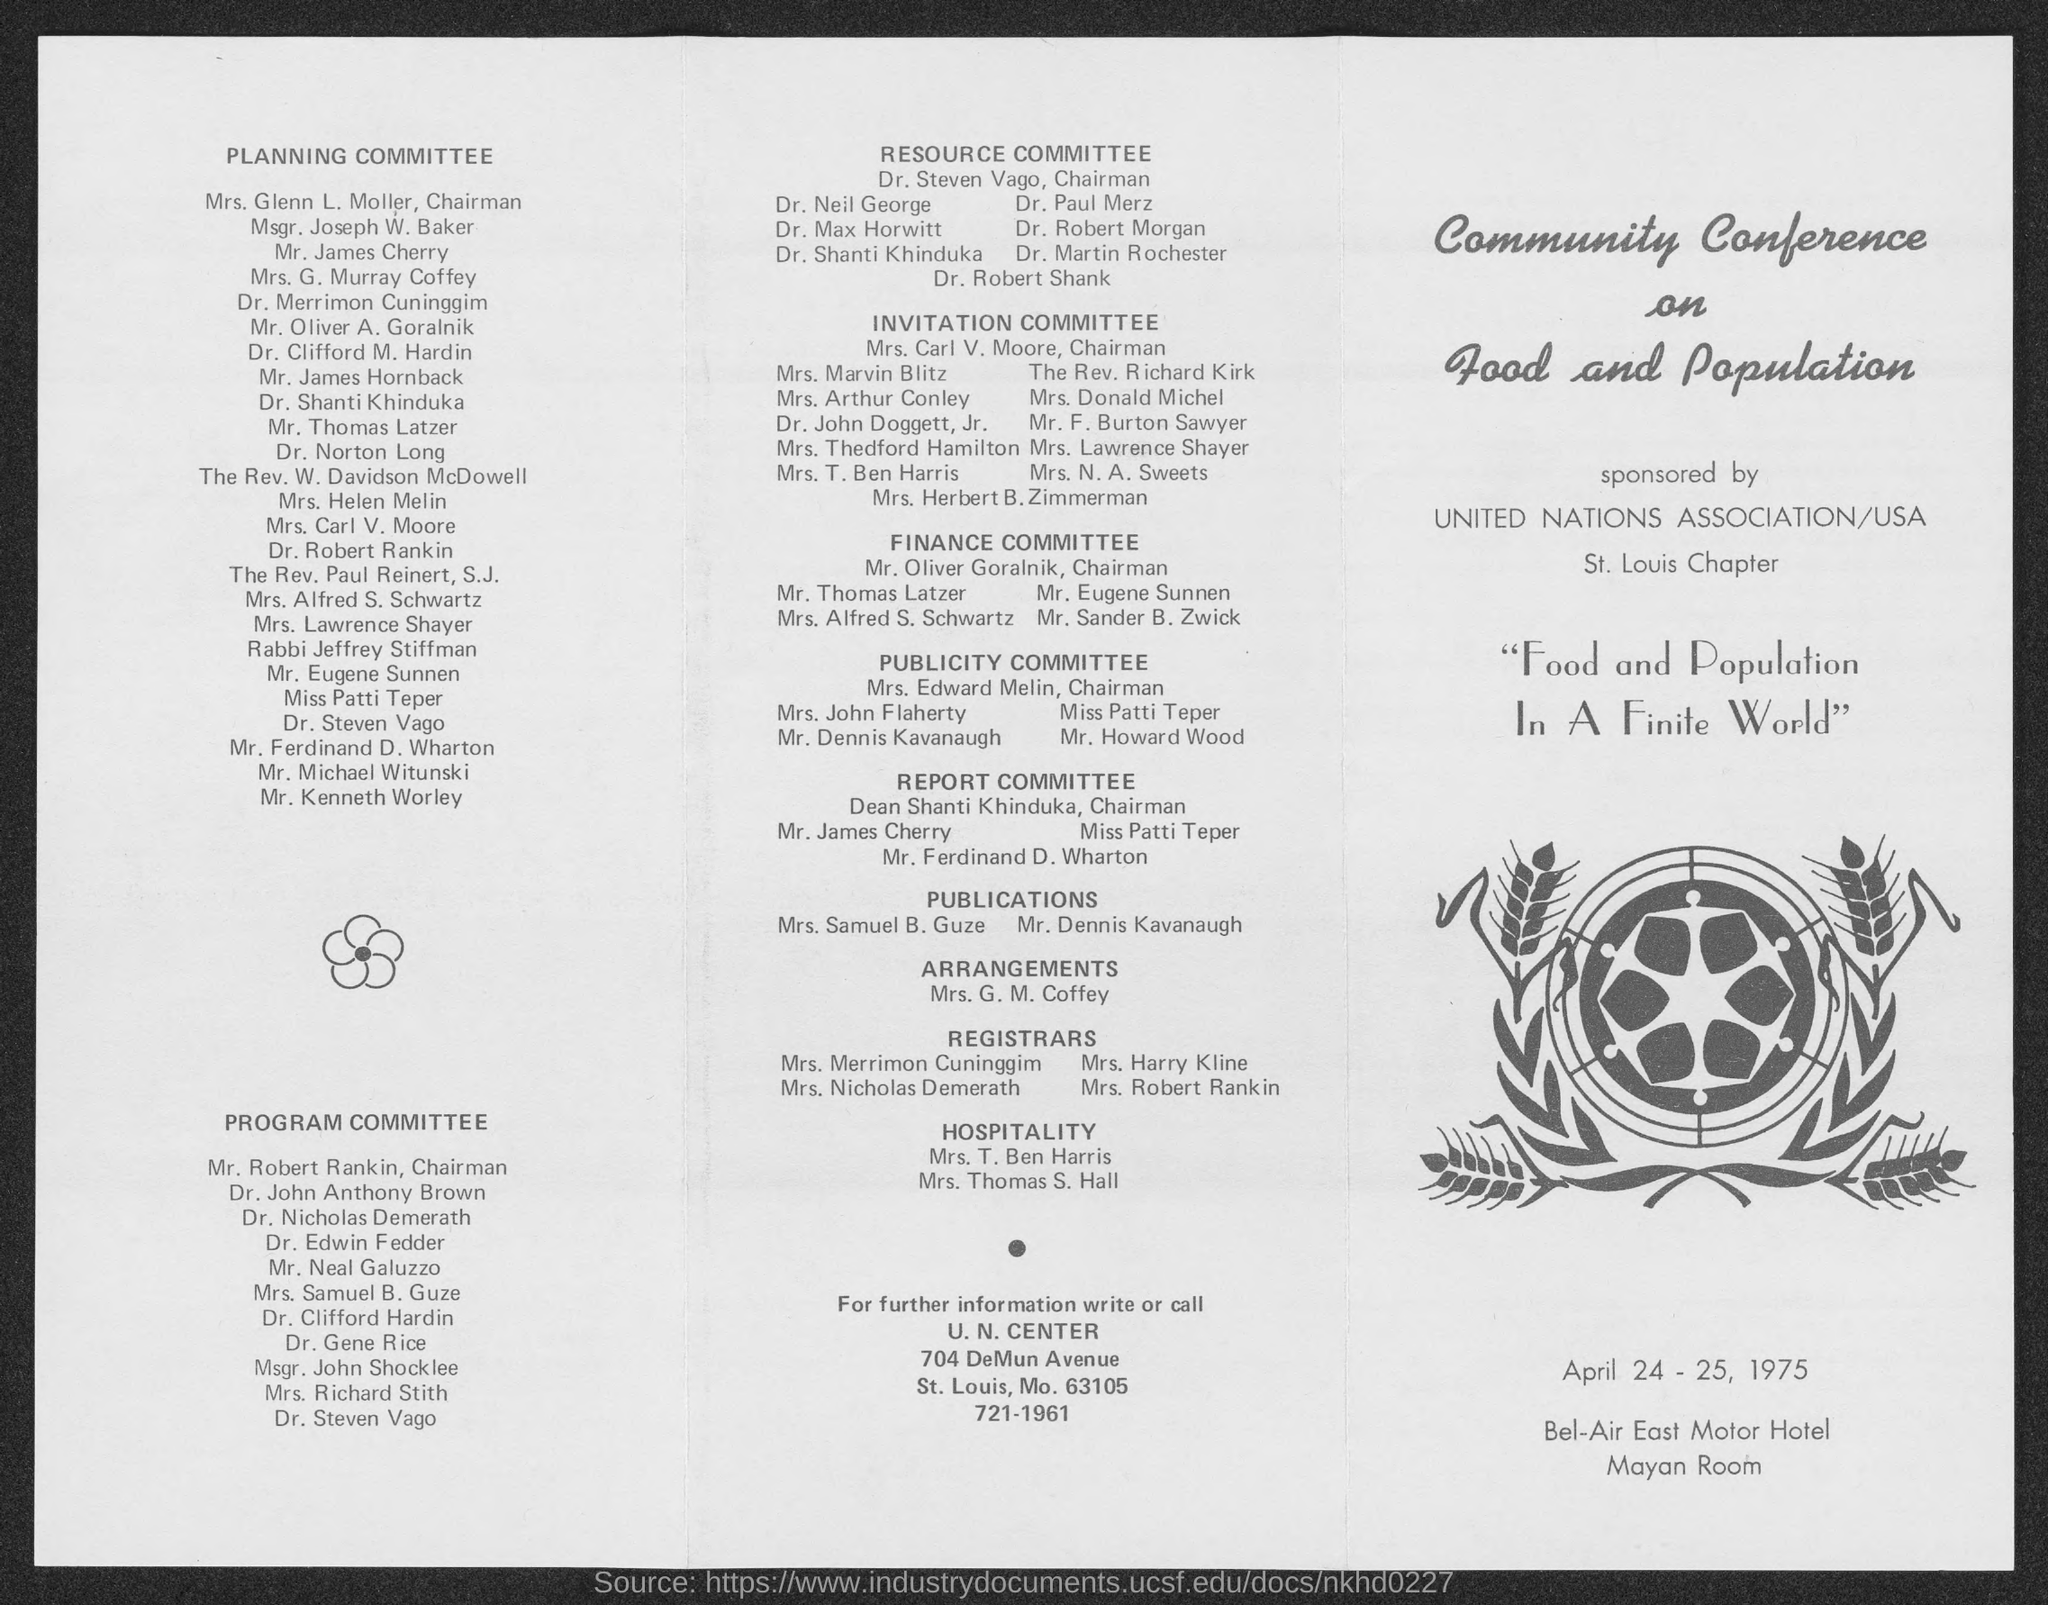Who sponsores Community Conference on Food and Population?
Keep it short and to the point. UNITED NATIONS ASSOCIATION/USA St. Lous Chapter. When was the Community Conference on Food and Population held?
Give a very brief answer. APRIL 24 - 25, 1975. In which place, the Community Conference on Food and Population is organized?
Give a very brief answer. Bel-Air East Motor Hotel Mayan Room. Who is the chairman of Planning Committe?
Keep it short and to the point. Mrs. Glenn L. Moller. What is the designation of Mr. Robert Rankin?
Provide a succinct answer. Chairman, PROGRAM COMMITTEE. Who is the chairman of Resource Committee?
Make the answer very short. Dr. Steven Vago. 